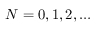Convert formula to latex. <formula><loc_0><loc_0><loc_500><loc_500>N = 0 , 1 , 2 , \dots</formula> 